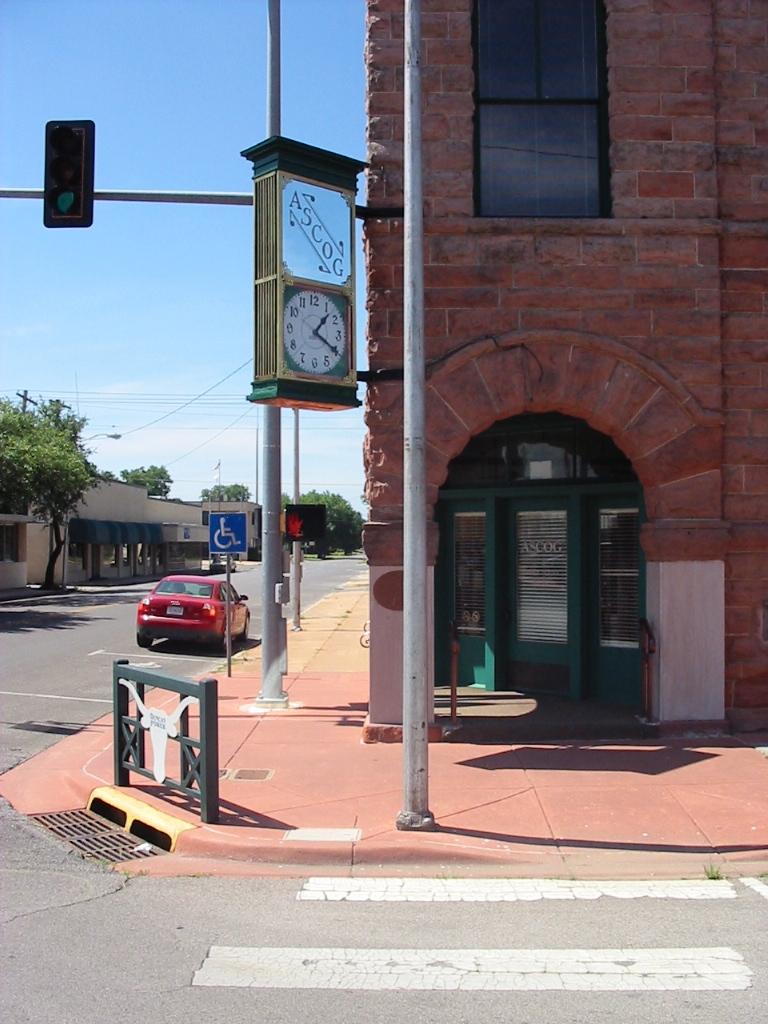What time is it?
Offer a terse response. 1:20. What does the letters above the clock say?
Ensure brevity in your answer.  Ascog. 